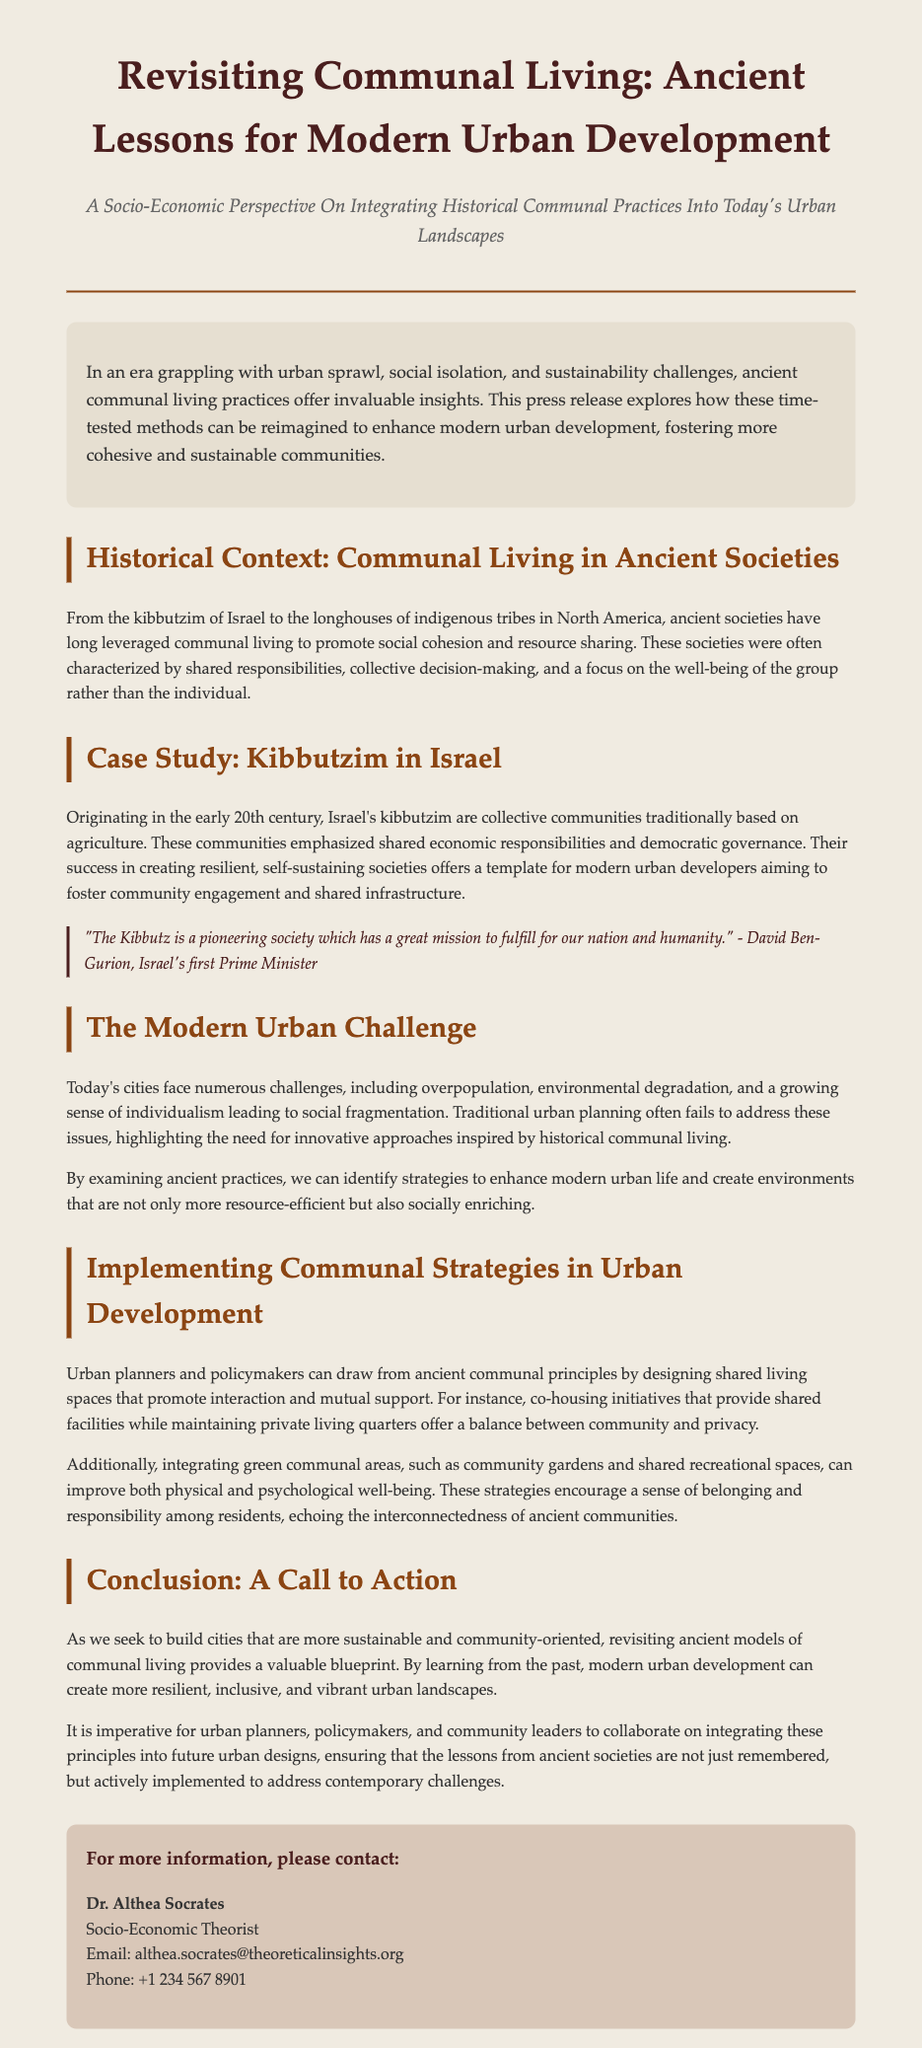What is the title of the press release? The title is the prominent heading at the top of the document, which outlines the main topic.
Answer: Revisiting Communal Living: Ancient Lessons for Modern Urban Development Who is the first contact listed in the contact information? This is the individual specified to provide more information, usually at the end of a press release.
Answer: Dr. Althea Socrates What ancient society is highlighted as a case study in the document? The case study section focuses on a specific group known for its communal living practices.
Answer: Kibbutzim in Israel What is one challenge faced by modern cities mentioned in the document? This is referenced in the section discussing contemporary urban issues, emphasizing the problems that need addressing.
Answer: Overpopulation What principle can urban planners integrate from ancient communal practices? This is a suggested strategy from the document that links historical practices to modern urban planning.
Answer: Shared living spaces What year did the kibbutzim in Israel originate? This information is related to the historical context provided in the document.
Answer: Early 20th century What is the main focus of communities in ancient societies as per the document? This describes the central value that these societies prioritized, which is discussed in various sections.
Answer: The well-being of the group What type of development does the press release encourage? The document calls for a specific approach to urban development inspired by historical insights.
Answer: Community-oriented urban development 